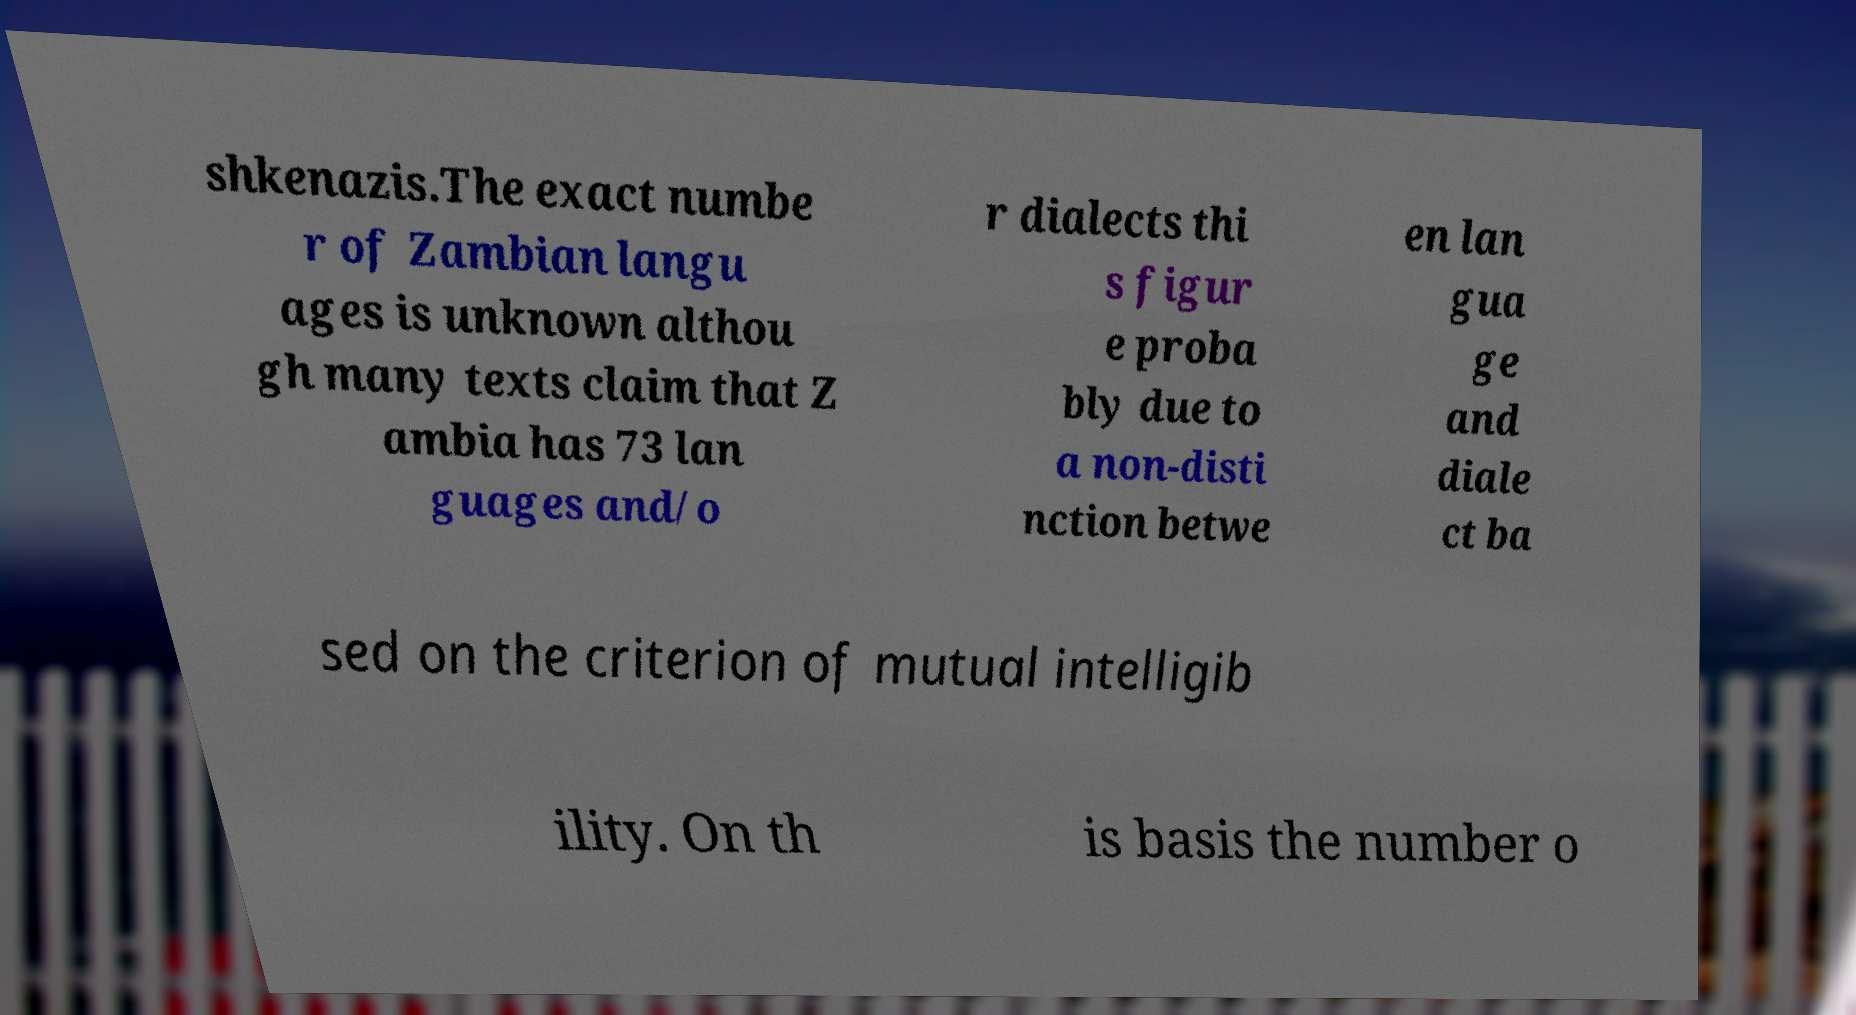Please identify and transcribe the text found in this image. shkenazis.The exact numbe r of Zambian langu ages is unknown althou gh many texts claim that Z ambia has 73 lan guages and/o r dialects thi s figur e proba bly due to a non-disti nction betwe en lan gua ge and diale ct ba sed on the criterion of mutual intelligib ility. On th is basis the number o 